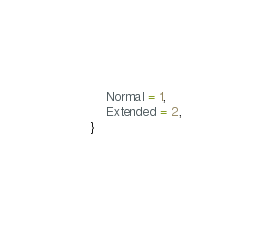<code> <loc_0><loc_0><loc_500><loc_500><_C#_>    Normal = 1,
    Extended = 2,
}
</code> 